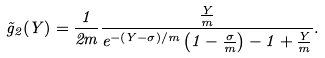<formula> <loc_0><loc_0><loc_500><loc_500>\tilde { g } _ { 2 } ( Y ) = \frac { 1 } { 2 m } \frac { \frac { Y } { m } } { e ^ { - ( Y - \sigma ) / m } \left ( 1 - \frac { \sigma } { m } \right ) - 1 + \frac { Y } { m } } .</formula> 